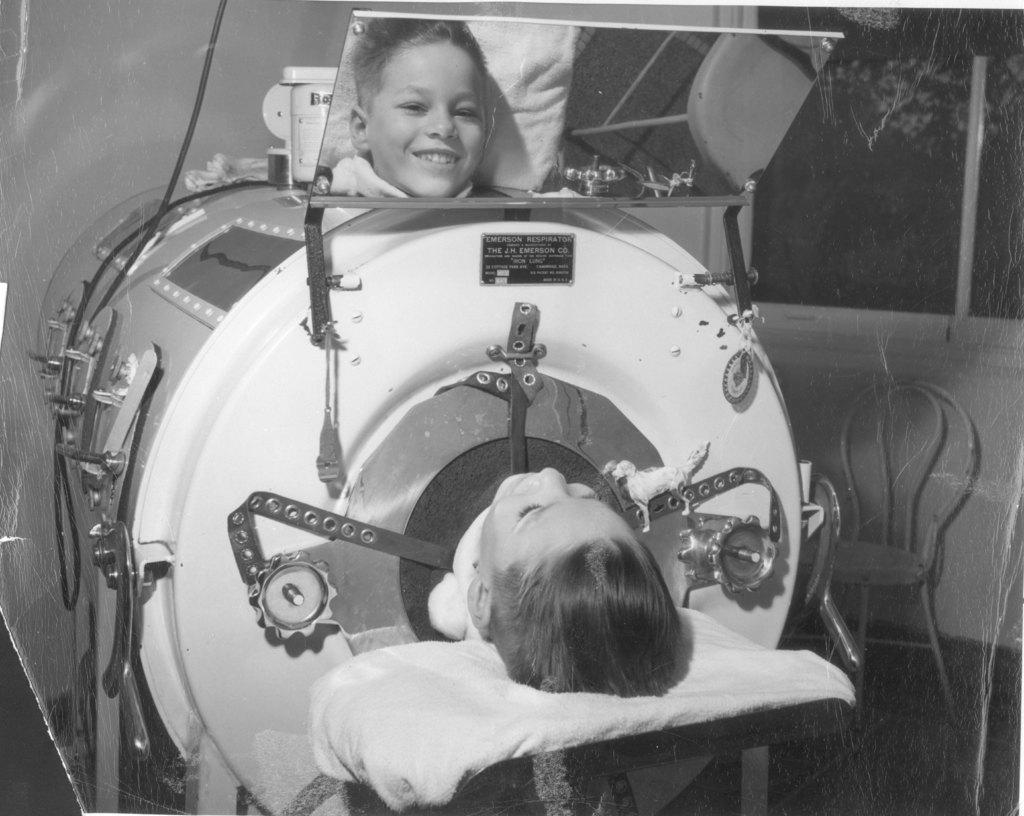What is the boy doing in the image? The boy is lying in the image. What object is present in the image that can show reflections? There is a mirror in the image. What can be seen in the mirror's reflection? The reflection of the boy is visible in the mirror. How does the mirror resemble a scanning machine? The mirror resembles a scanning machine due to its shape and appearance. Can you see any toothbrushes on the farm in the image? There is no farm or toothbrush present in the image. 